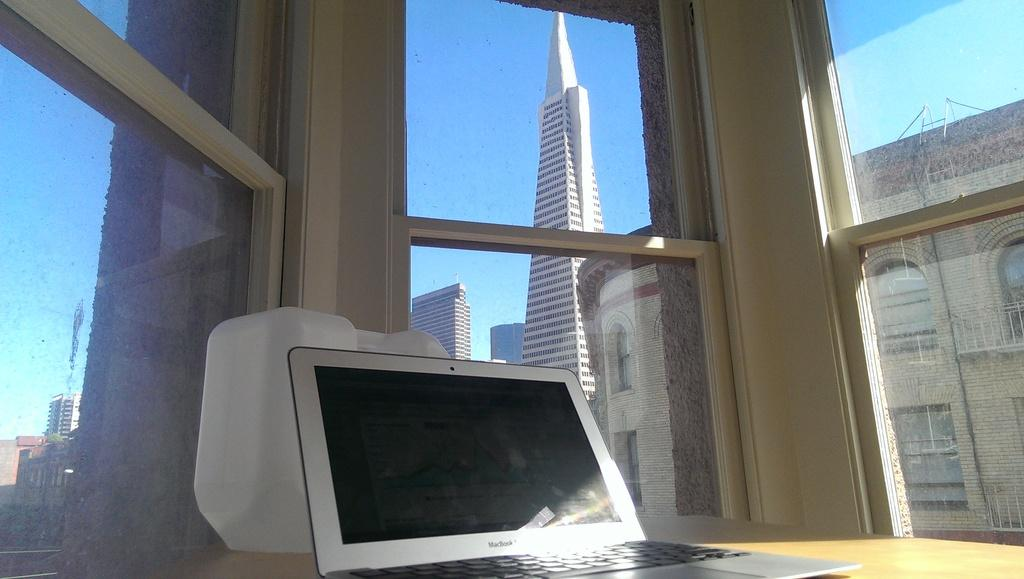What electronic device is visible in the image? There is a laptop in the image. What is located on the table in the image? There is an object on the table in the image. What feature allows natural light to enter the room in the image? There is a window in the image. What can be seen in the distance in the image? There are buildings visible in the background of the image. What is visible above the buildings in the image? The sky is visible in the background of the image. How does the ladybug express regret in the image? There is no ladybug present in the image, so it cannot express regret. 